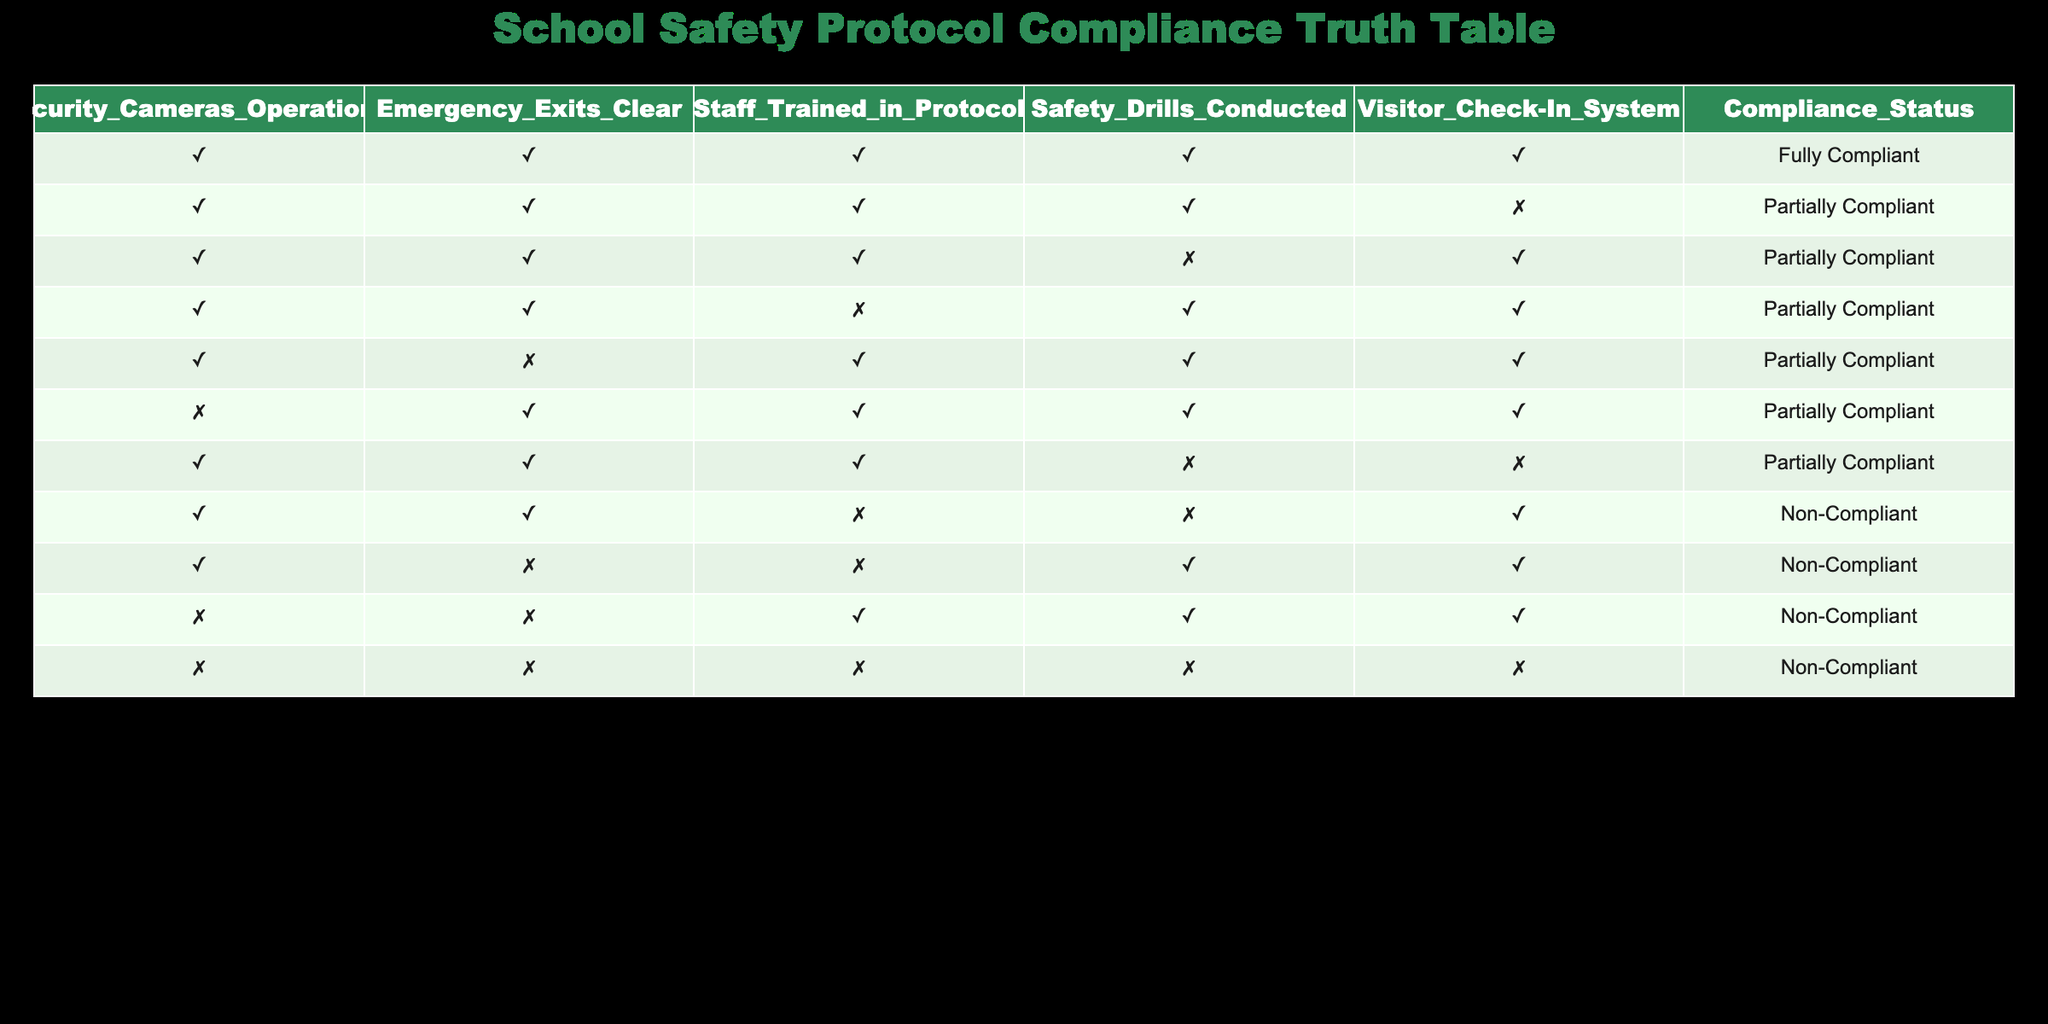What is the compliance status when all factors are true? When all factors are true, the compliance status is listed in the first row of the table, which indicates "Fully Compliant."
Answer: Fully Compliant How many conditions must be met for a school to be considered "Non-Compliant"? By analyzing the table, "Non-Compliant" is indicated in rows where at least two conditions are false (shown in the last five rows). Therefore, to be "Non-Compliant," at least two out of the five conditions must not be met.
Answer: 2 What is the compliance status when the Visitor Check-In System is false? Reviewing the table, there are rows where the Visitor Check-In System is false. These rows indicate that the compliance status is either "Partially Compliant" or "Non-Compliant." It does not indicate "Fully Compliant."
Answer: No Fully Compliant How many total entries in the table show "Partially Compliant"? To find the total entries for "Partially Compliant," one must count the relevant rows, which are 6 in total based on the data given.
Answer: 6 Is it true that compliance status is "Non-Compliant" when security cameras are not operational? Rows in the table show that if security cameras are not operational (rows with "FALSE" under Security Cameras Operational), the compliance status is "Partially Compliant" or "Non-Compliant." Therefore, it is indeed true that at least one entry shows "Non-Compliant."
Answer: Yes 